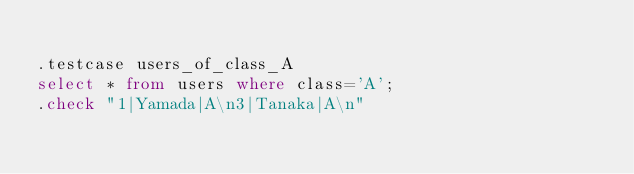<code> <loc_0><loc_0><loc_500><loc_500><_SQL_>
.testcase users_of_class_A
select * from users where class='A';
.check "1|Yamada|A\n3|Tanaka|A\n"

</code> 